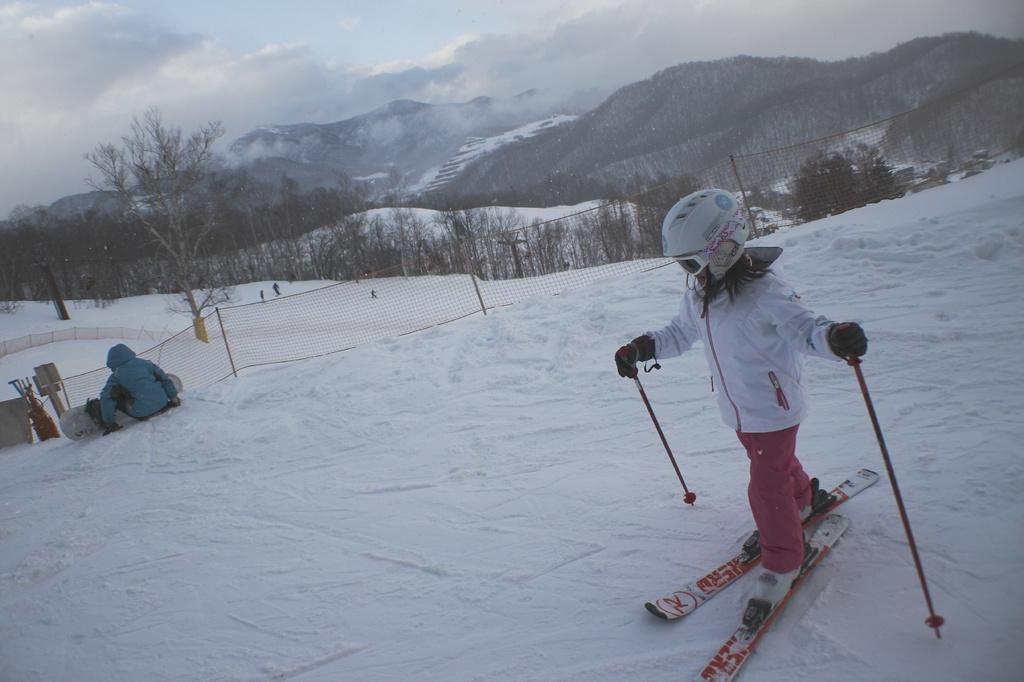Can you describe this image briefly? In this picture we can see couple of people a boy is skiing in the ice and we can find net and couple of trees. 